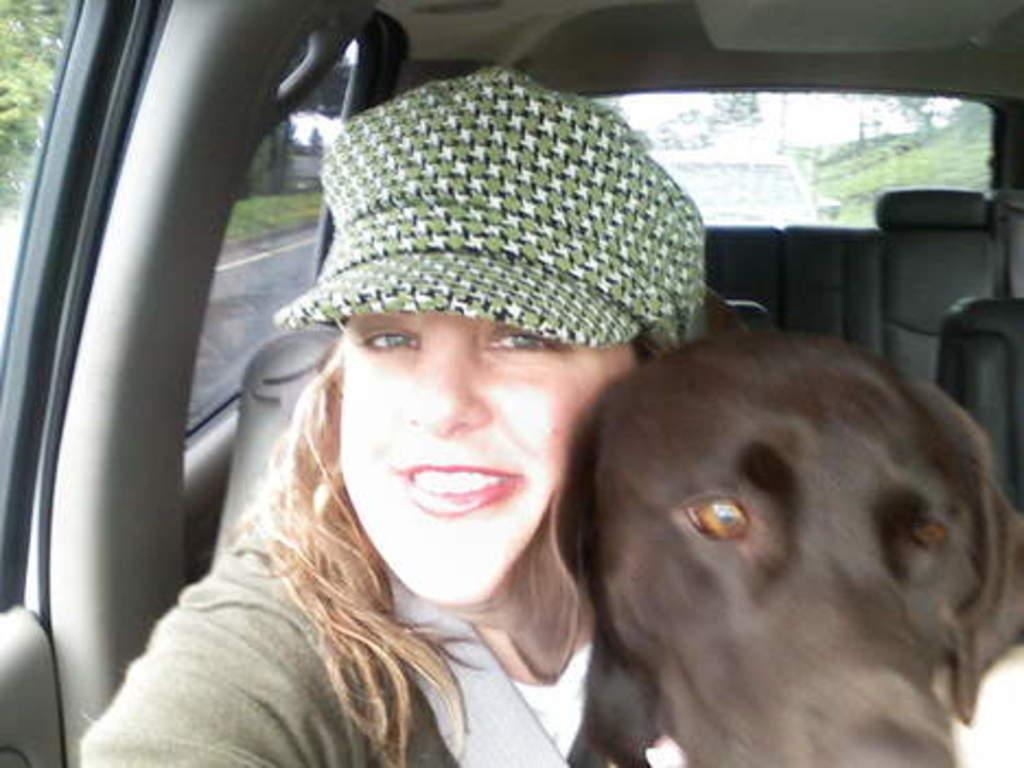In one or two sentences, can you explain what this image depicts? In this picture we can see a woman wearing a cap and she is smiling. We can see the face of a dog. This is an inside view of a car. We can see the seats, seat belt, road, green grass and trees. 